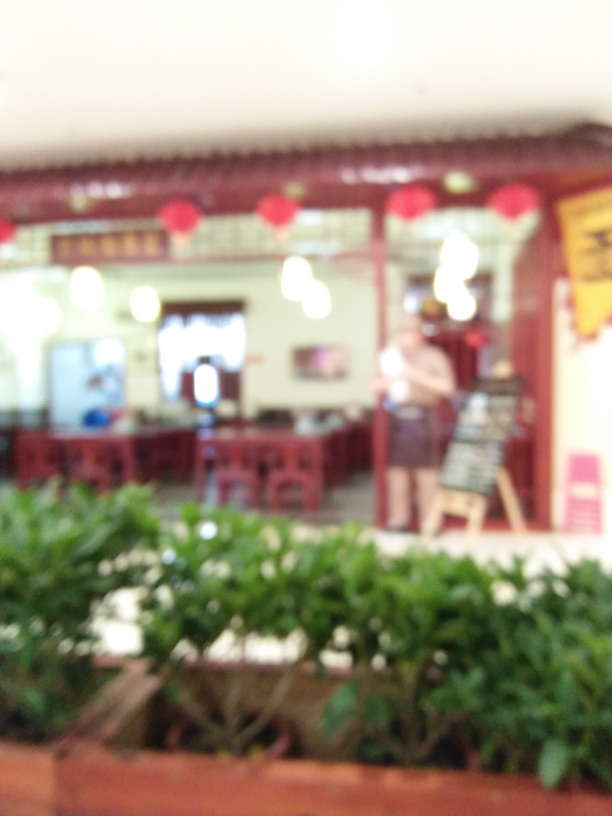Is the image perfectly straight? It's challenging to determine if the image is perfectly straight due to the significant blur. However, the overall impression suggests that the image might not be perfectly aligned, as the structures within it appear to have some degree of tilt to the left. 